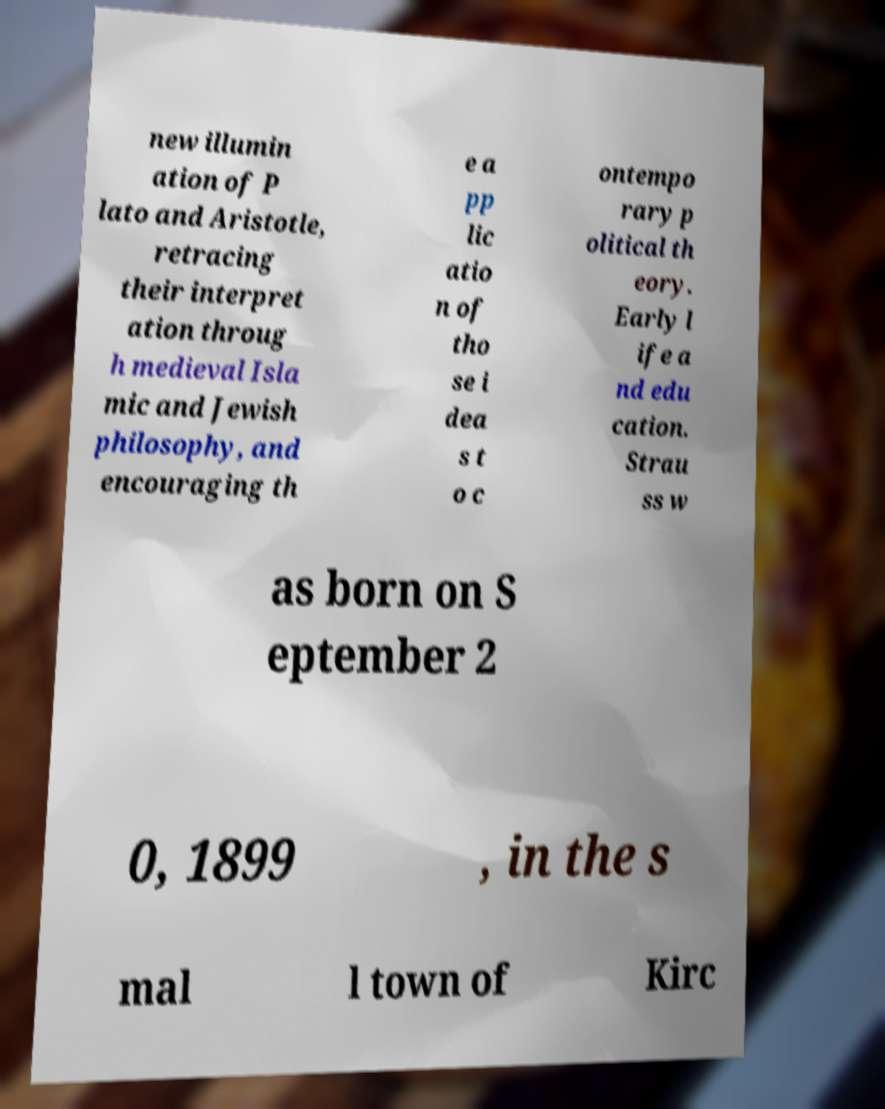Could you extract and type out the text from this image? new illumin ation of P lato and Aristotle, retracing their interpret ation throug h medieval Isla mic and Jewish philosophy, and encouraging th e a pp lic atio n of tho se i dea s t o c ontempo rary p olitical th eory. Early l ife a nd edu cation. Strau ss w as born on S eptember 2 0, 1899 , in the s mal l town of Kirc 